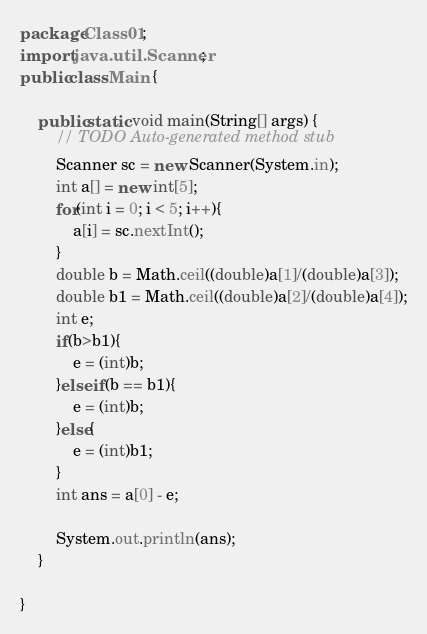<code> <loc_0><loc_0><loc_500><loc_500><_Java_>package Class01;
import java.util.Scanner;
public class Main {

	public static void main(String[] args) {
		// TODO Auto-generated method stub
		Scanner sc = new Scanner(System.in);
		int a[] = new int[5];
		for(int i = 0; i < 5; i++){
			a[i] = sc.nextInt();
		}
		double b = Math.ceil((double)a[1]/(double)a[3]);
		double b1 = Math.ceil((double)a[2]/(double)a[4]);
		int e;
		if(b>b1){
			e = (int)b;
		}else if(b == b1){
			e = (int)b;
		}else{
			e = (int)b1;
		}
		int ans = a[0] - e;
		
		System.out.println(ans);
	}

}</code> 